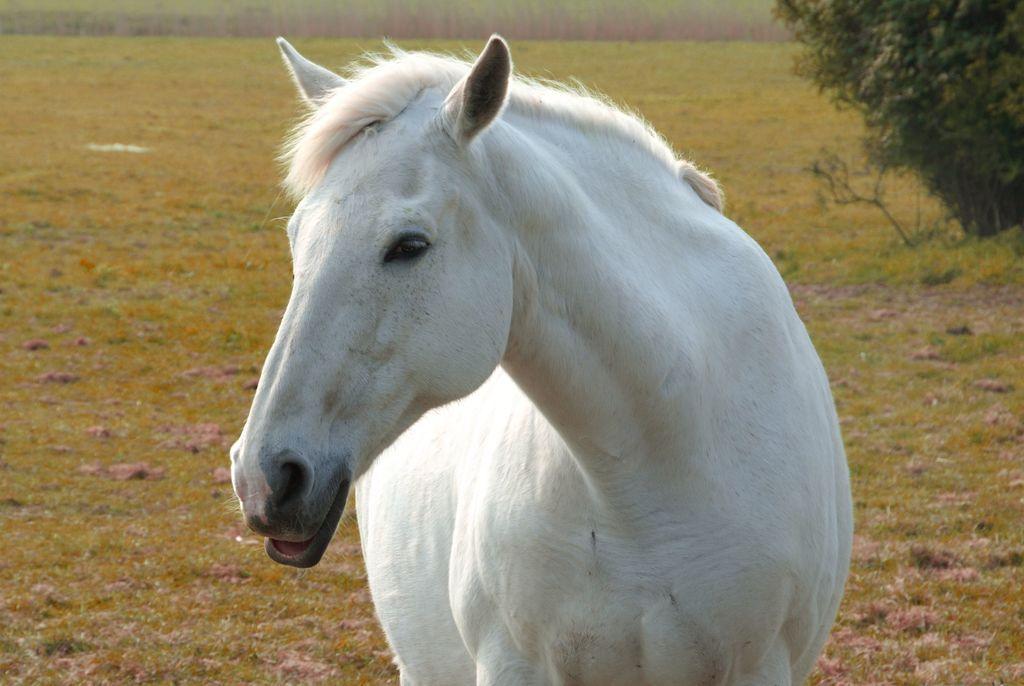Please provide a concise description of this image. In this image I can see a horse which is white and black in color is standing on the road. I can see some grass on the ground and a tree which is green in color. 